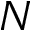<formula> <loc_0><loc_0><loc_500><loc_500>N</formula> 